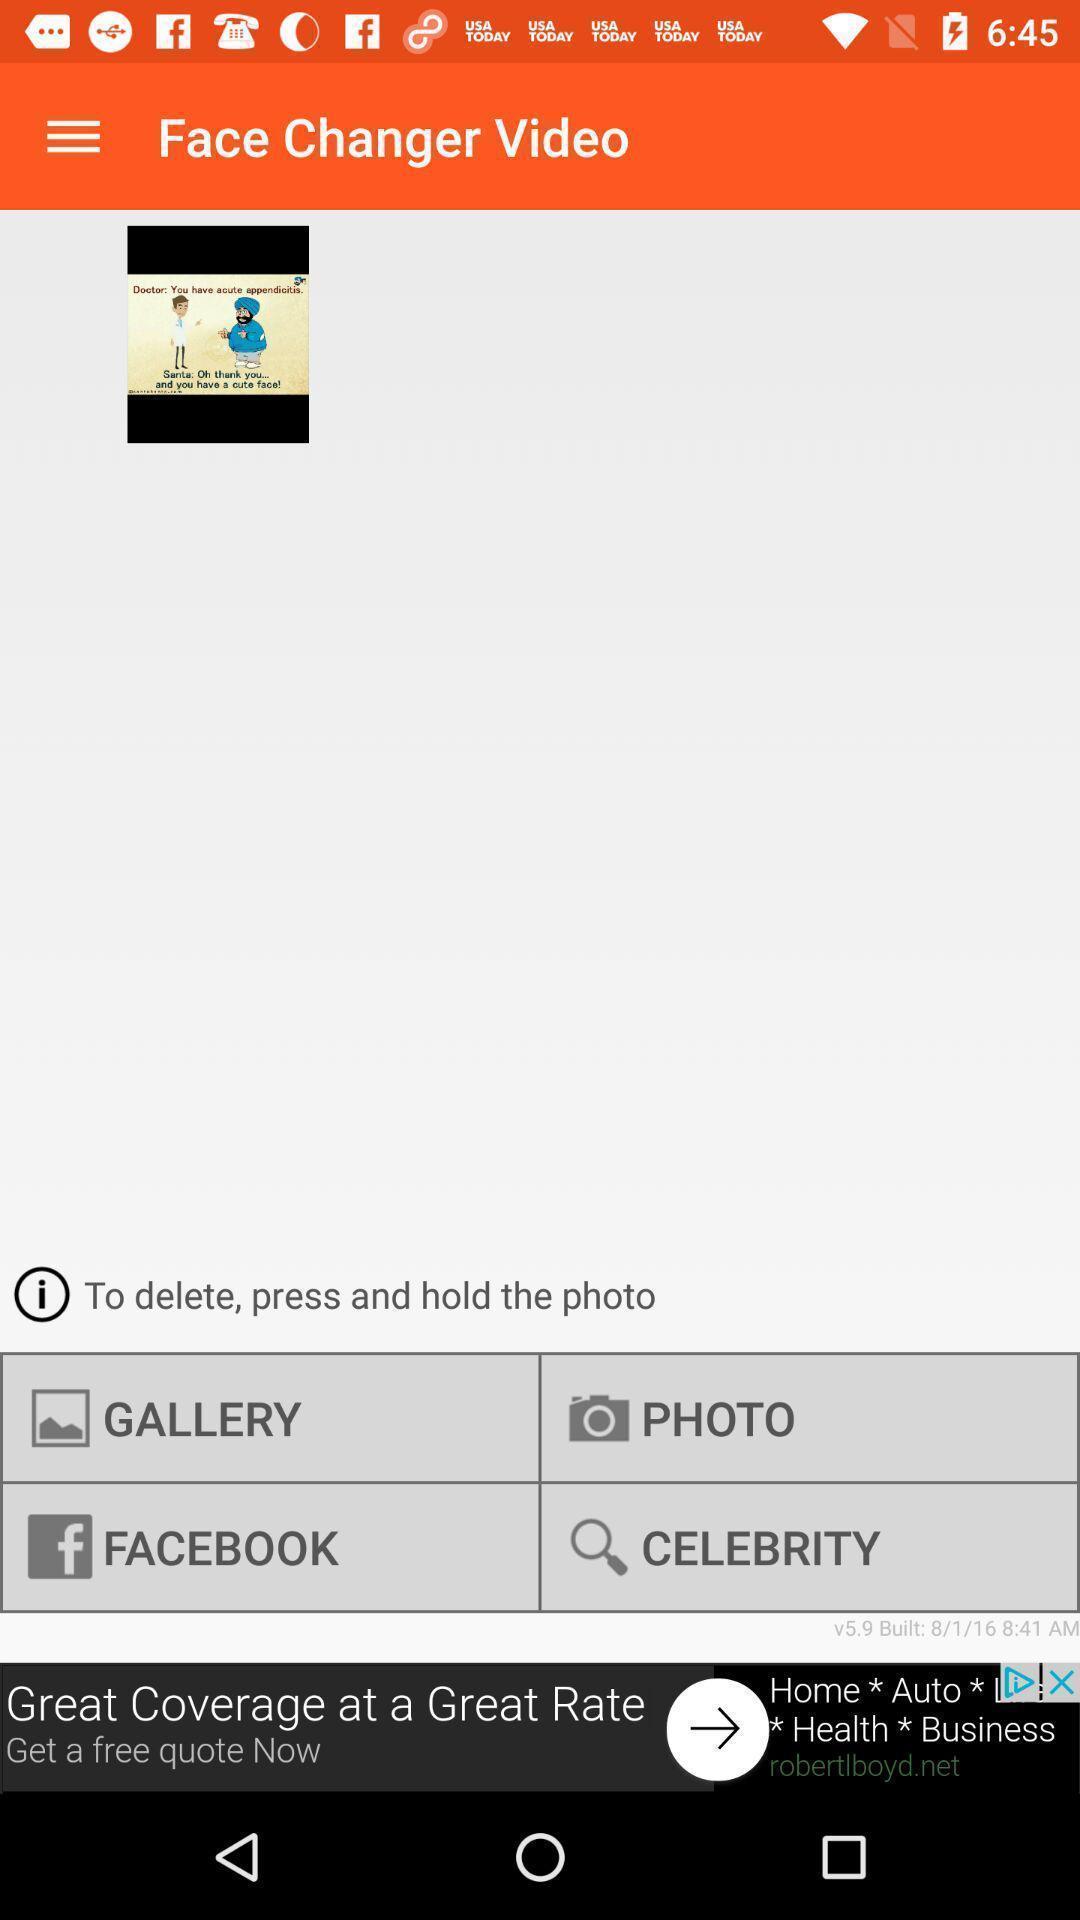What is the overall content of this screenshot? Screen shows a face changer video application. 